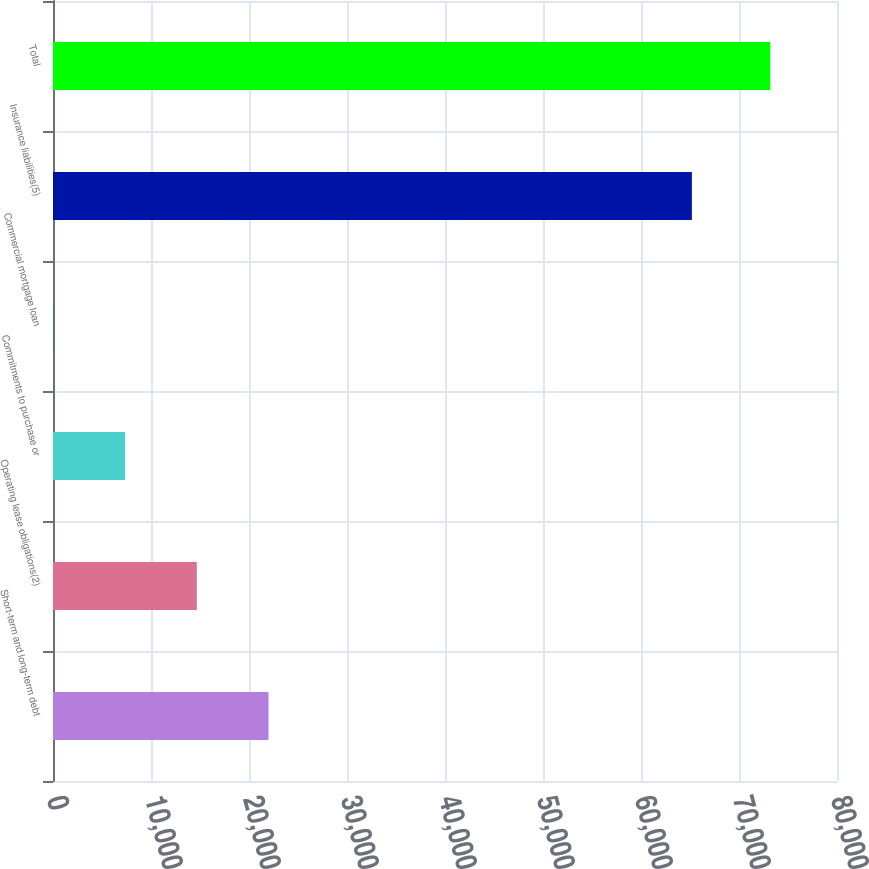Convert chart. <chart><loc_0><loc_0><loc_500><loc_500><bar_chart><fcel>Short-term and long-term debt<fcel>Operating lease obligations(2)<fcel>Commitments to purchase or<fcel>Commercial mortgage loan<fcel>Insurance liabilities(5)<fcel>Total<nl><fcel>21989.3<fcel>14674.2<fcel>7359.1<fcel>44<fcel>65192<fcel>73195<nl></chart> 